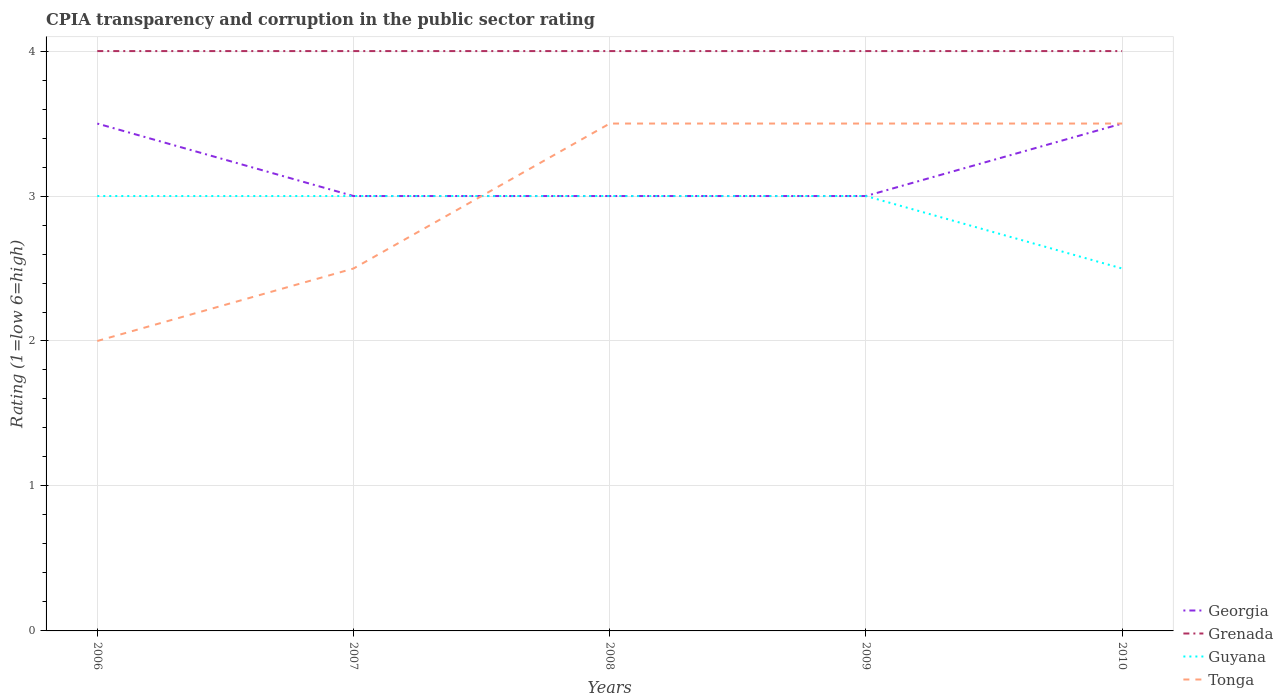How many different coloured lines are there?
Ensure brevity in your answer.  4. Does the line corresponding to Guyana intersect with the line corresponding to Grenada?
Your answer should be compact. No. Is the number of lines equal to the number of legend labels?
Keep it short and to the point. Yes. Across all years, what is the maximum CPIA rating in Georgia?
Give a very brief answer. 3. In which year was the CPIA rating in Guyana maximum?
Offer a terse response. 2010. What is the total CPIA rating in Tonga in the graph?
Your answer should be very brief. -1. What is the difference between the highest and the lowest CPIA rating in Guyana?
Your answer should be compact. 4. How many lines are there?
Your answer should be very brief. 4. How many years are there in the graph?
Your answer should be compact. 5. Are the values on the major ticks of Y-axis written in scientific E-notation?
Your answer should be compact. No. Does the graph contain any zero values?
Offer a terse response. No. Where does the legend appear in the graph?
Provide a succinct answer. Bottom right. How are the legend labels stacked?
Your answer should be compact. Vertical. What is the title of the graph?
Provide a succinct answer. CPIA transparency and corruption in the public sector rating. What is the label or title of the X-axis?
Ensure brevity in your answer.  Years. What is the label or title of the Y-axis?
Give a very brief answer. Rating (1=low 6=high). What is the Rating (1=low 6=high) in Georgia in 2006?
Your response must be concise. 3.5. What is the Rating (1=low 6=high) in Grenada in 2006?
Your answer should be very brief. 4. What is the Rating (1=low 6=high) in Georgia in 2007?
Give a very brief answer. 3. What is the Rating (1=low 6=high) of Grenada in 2007?
Offer a terse response. 4. What is the Rating (1=low 6=high) in Tonga in 2007?
Give a very brief answer. 2.5. What is the Rating (1=low 6=high) of Guyana in 2008?
Offer a terse response. 3. What is the Rating (1=low 6=high) of Georgia in 2010?
Keep it short and to the point. 3.5. Across all years, what is the maximum Rating (1=low 6=high) in Georgia?
Ensure brevity in your answer.  3.5. Across all years, what is the minimum Rating (1=low 6=high) of Georgia?
Offer a very short reply. 3. Across all years, what is the minimum Rating (1=low 6=high) of Guyana?
Ensure brevity in your answer.  2.5. Across all years, what is the minimum Rating (1=low 6=high) in Tonga?
Your response must be concise. 2. What is the difference between the Rating (1=low 6=high) of Georgia in 2006 and that in 2007?
Your answer should be very brief. 0.5. What is the difference between the Rating (1=low 6=high) of Guyana in 2006 and that in 2007?
Your response must be concise. 0. What is the difference between the Rating (1=low 6=high) in Tonga in 2006 and that in 2007?
Make the answer very short. -0.5. What is the difference between the Rating (1=low 6=high) of Grenada in 2006 and that in 2008?
Offer a terse response. 0. What is the difference between the Rating (1=low 6=high) in Tonga in 2006 and that in 2008?
Keep it short and to the point. -1.5. What is the difference between the Rating (1=low 6=high) of Georgia in 2006 and that in 2009?
Your response must be concise. 0.5. What is the difference between the Rating (1=low 6=high) in Guyana in 2006 and that in 2009?
Your response must be concise. 0. What is the difference between the Rating (1=low 6=high) of Georgia in 2006 and that in 2010?
Your answer should be compact. 0. What is the difference between the Rating (1=low 6=high) of Guyana in 2006 and that in 2010?
Provide a succinct answer. 0.5. What is the difference between the Rating (1=low 6=high) of Grenada in 2007 and that in 2008?
Your answer should be very brief. 0. What is the difference between the Rating (1=low 6=high) of Georgia in 2007 and that in 2009?
Make the answer very short. 0. What is the difference between the Rating (1=low 6=high) of Tonga in 2007 and that in 2009?
Offer a terse response. -1. What is the difference between the Rating (1=low 6=high) of Georgia in 2007 and that in 2010?
Give a very brief answer. -0.5. What is the difference between the Rating (1=low 6=high) of Guyana in 2007 and that in 2010?
Your answer should be very brief. 0.5. What is the difference between the Rating (1=low 6=high) of Tonga in 2007 and that in 2010?
Offer a very short reply. -1. What is the difference between the Rating (1=low 6=high) in Georgia in 2008 and that in 2010?
Provide a succinct answer. -0.5. What is the difference between the Rating (1=low 6=high) in Guyana in 2008 and that in 2010?
Provide a succinct answer. 0.5. What is the difference between the Rating (1=low 6=high) of Tonga in 2008 and that in 2010?
Your response must be concise. 0. What is the difference between the Rating (1=low 6=high) of Grenada in 2009 and that in 2010?
Offer a terse response. 0. What is the difference between the Rating (1=low 6=high) in Guyana in 2009 and that in 2010?
Make the answer very short. 0.5. What is the difference between the Rating (1=low 6=high) of Grenada in 2006 and the Rating (1=low 6=high) of Guyana in 2007?
Keep it short and to the point. 1. What is the difference between the Rating (1=low 6=high) in Grenada in 2006 and the Rating (1=low 6=high) in Tonga in 2007?
Ensure brevity in your answer.  1.5. What is the difference between the Rating (1=low 6=high) of Georgia in 2006 and the Rating (1=low 6=high) of Grenada in 2008?
Ensure brevity in your answer.  -0.5. What is the difference between the Rating (1=low 6=high) in Georgia in 2006 and the Rating (1=low 6=high) in Guyana in 2008?
Your answer should be compact. 0.5. What is the difference between the Rating (1=low 6=high) of Guyana in 2006 and the Rating (1=low 6=high) of Tonga in 2008?
Provide a short and direct response. -0.5. What is the difference between the Rating (1=low 6=high) of Georgia in 2006 and the Rating (1=low 6=high) of Grenada in 2009?
Your response must be concise. -0.5. What is the difference between the Rating (1=low 6=high) in Georgia in 2006 and the Rating (1=low 6=high) in Guyana in 2009?
Your answer should be very brief. 0.5. What is the difference between the Rating (1=low 6=high) in Georgia in 2006 and the Rating (1=low 6=high) in Grenada in 2010?
Your response must be concise. -0.5. What is the difference between the Rating (1=low 6=high) in Georgia in 2006 and the Rating (1=low 6=high) in Tonga in 2010?
Your answer should be compact. 0. What is the difference between the Rating (1=low 6=high) of Grenada in 2006 and the Rating (1=low 6=high) of Tonga in 2010?
Your response must be concise. 0.5. What is the difference between the Rating (1=low 6=high) in Guyana in 2006 and the Rating (1=low 6=high) in Tonga in 2010?
Your response must be concise. -0.5. What is the difference between the Rating (1=low 6=high) in Georgia in 2007 and the Rating (1=low 6=high) in Grenada in 2008?
Offer a very short reply. -1. What is the difference between the Rating (1=low 6=high) of Georgia in 2007 and the Rating (1=low 6=high) of Tonga in 2008?
Offer a terse response. -0.5. What is the difference between the Rating (1=low 6=high) of Grenada in 2007 and the Rating (1=low 6=high) of Guyana in 2008?
Your response must be concise. 1. What is the difference between the Rating (1=low 6=high) in Grenada in 2007 and the Rating (1=low 6=high) in Tonga in 2008?
Make the answer very short. 0.5. What is the difference between the Rating (1=low 6=high) of Georgia in 2007 and the Rating (1=low 6=high) of Grenada in 2009?
Ensure brevity in your answer.  -1. What is the difference between the Rating (1=low 6=high) in Grenada in 2007 and the Rating (1=low 6=high) in Guyana in 2009?
Your answer should be very brief. 1. What is the difference between the Rating (1=low 6=high) of Grenada in 2007 and the Rating (1=low 6=high) of Tonga in 2009?
Your answer should be very brief. 0.5. What is the difference between the Rating (1=low 6=high) of Guyana in 2007 and the Rating (1=low 6=high) of Tonga in 2009?
Ensure brevity in your answer.  -0.5. What is the difference between the Rating (1=low 6=high) of Georgia in 2007 and the Rating (1=low 6=high) of Grenada in 2010?
Your answer should be compact. -1. What is the difference between the Rating (1=low 6=high) of Georgia in 2007 and the Rating (1=low 6=high) of Guyana in 2010?
Make the answer very short. 0.5. What is the difference between the Rating (1=low 6=high) in Guyana in 2007 and the Rating (1=low 6=high) in Tonga in 2010?
Offer a very short reply. -0.5. What is the difference between the Rating (1=low 6=high) in Georgia in 2008 and the Rating (1=low 6=high) in Grenada in 2009?
Offer a very short reply. -1. What is the difference between the Rating (1=low 6=high) in Georgia in 2008 and the Rating (1=low 6=high) in Tonga in 2010?
Offer a terse response. -0.5. What is the difference between the Rating (1=low 6=high) of Grenada in 2008 and the Rating (1=low 6=high) of Guyana in 2010?
Give a very brief answer. 1.5. What is the difference between the Rating (1=low 6=high) of Grenada in 2008 and the Rating (1=low 6=high) of Tonga in 2010?
Ensure brevity in your answer.  0.5. What is the difference between the Rating (1=low 6=high) in Georgia in 2009 and the Rating (1=low 6=high) in Grenada in 2010?
Give a very brief answer. -1. What is the difference between the Rating (1=low 6=high) of Georgia in 2009 and the Rating (1=low 6=high) of Guyana in 2010?
Provide a succinct answer. 0.5. What is the difference between the Rating (1=low 6=high) in Grenada in 2009 and the Rating (1=low 6=high) in Guyana in 2010?
Ensure brevity in your answer.  1.5. What is the difference between the Rating (1=low 6=high) of Grenada in 2009 and the Rating (1=low 6=high) of Tonga in 2010?
Offer a terse response. 0.5. What is the average Rating (1=low 6=high) of Georgia per year?
Your answer should be very brief. 3.2. What is the average Rating (1=low 6=high) in Grenada per year?
Make the answer very short. 4. What is the average Rating (1=low 6=high) of Tonga per year?
Provide a short and direct response. 3. In the year 2006, what is the difference between the Rating (1=low 6=high) in Georgia and Rating (1=low 6=high) in Guyana?
Keep it short and to the point. 0.5. In the year 2006, what is the difference between the Rating (1=low 6=high) in Georgia and Rating (1=low 6=high) in Tonga?
Your response must be concise. 1.5. In the year 2006, what is the difference between the Rating (1=low 6=high) of Grenada and Rating (1=low 6=high) of Tonga?
Make the answer very short. 2. In the year 2007, what is the difference between the Rating (1=low 6=high) of Grenada and Rating (1=low 6=high) of Guyana?
Give a very brief answer. 1. In the year 2007, what is the difference between the Rating (1=low 6=high) of Guyana and Rating (1=low 6=high) of Tonga?
Your answer should be very brief. 0.5. In the year 2008, what is the difference between the Rating (1=low 6=high) in Georgia and Rating (1=low 6=high) in Grenada?
Your answer should be compact. -1. In the year 2008, what is the difference between the Rating (1=low 6=high) of Grenada and Rating (1=low 6=high) of Tonga?
Provide a short and direct response. 0.5. In the year 2009, what is the difference between the Rating (1=low 6=high) of Grenada and Rating (1=low 6=high) of Guyana?
Offer a very short reply. 1. In the year 2010, what is the difference between the Rating (1=low 6=high) in Georgia and Rating (1=low 6=high) in Grenada?
Offer a very short reply. -0.5. In the year 2010, what is the difference between the Rating (1=low 6=high) of Guyana and Rating (1=low 6=high) of Tonga?
Give a very brief answer. -1. What is the ratio of the Rating (1=low 6=high) of Grenada in 2006 to that in 2007?
Give a very brief answer. 1. What is the ratio of the Rating (1=low 6=high) of Guyana in 2006 to that in 2007?
Keep it short and to the point. 1. What is the ratio of the Rating (1=low 6=high) in Grenada in 2006 to that in 2008?
Give a very brief answer. 1. What is the ratio of the Rating (1=low 6=high) in Guyana in 2006 to that in 2008?
Your answer should be very brief. 1. What is the ratio of the Rating (1=low 6=high) of Grenada in 2006 to that in 2010?
Ensure brevity in your answer.  1. What is the ratio of the Rating (1=low 6=high) in Grenada in 2007 to that in 2008?
Keep it short and to the point. 1. What is the ratio of the Rating (1=low 6=high) of Tonga in 2007 to that in 2008?
Offer a very short reply. 0.71. What is the ratio of the Rating (1=low 6=high) of Grenada in 2007 to that in 2010?
Keep it short and to the point. 1. What is the ratio of the Rating (1=low 6=high) of Guyana in 2007 to that in 2010?
Make the answer very short. 1.2. What is the ratio of the Rating (1=low 6=high) of Tonga in 2007 to that in 2010?
Make the answer very short. 0.71. What is the ratio of the Rating (1=low 6=high) in Georgia in 2008 to that in 2009?
Give a very brief answer. 1. What is the ratio of the Rating (1=low 6=high) of Grenada in 2008 to that in 2009?
Make the answer very short. 1. What is the ratio of the Rating (1=low 6=high) in Guyana in 2008 to that in 2009?
Ensure brevity in your answer.  1. What is the ratio of the Rating (1=low 6=high) of Georgia in 2008 to that in 2010?
Make the answer very short. 0.86. What is the ratio of the Rating (1=low 6=high) of Grenada in 2009 to that in 2010?
Your answer should be compact. 1. What is the ratio of the Rating (1=low 6=high) of Tonga in 2009 to that in 2010?
Make the answer very short. 1. What is the difference between the highest and the second highest Rating (1=low 6=high) of Georgia?
Offer a very short reply. 0. What is the difference between the highest and the second highest Rating (1=low 6=high) in Grenada?
Keep it short and to the point. 0. What is the difference between the highest and the second highest Rating (1=low 6=high) in Guyana?
Your response must be concise. 0. What is the difference between the highest and the lowest Rating (1=low 6=high) in Georgia?
Keep it short and to the point. 0.5. What is the difference between the highest and the lowest Rating (1=low 6=high) of Grenada?
Offer a very short reply. 0. What is the difference between the highest and the lowest Rating (1=low 6=high) of Guyana?
Your answer should be very brief. 0.5. What is the difference between the highest and the lowest Rating (1=low 6=high) in Tonga?
Your answer should be very brief. 1.5. 